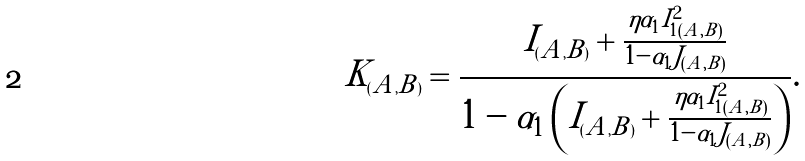Convert formula to latex. <formula><loc_0><loc_0><loc_500><loc_500>K _ { ( A , B ) } = \frac { I _ { ( A , B ) } + \frac { \eta \alpha _ { 1 } I _ { 1 ( A , B ) } ^ { 2 } } { 1 - \alpha _ { 1 } J _ { ( A , B ) } } } { 1 - \alpha _ { 1 } \left ( I _ { ( A , B ) } + \frac { \eta \alpha _ { 1 } I _ { 1 ( A , B ) } ^ { 2 } } { 1 - \alpha _ { 1 } J _ { ( A , B ) } } \right ) } .</formula> 